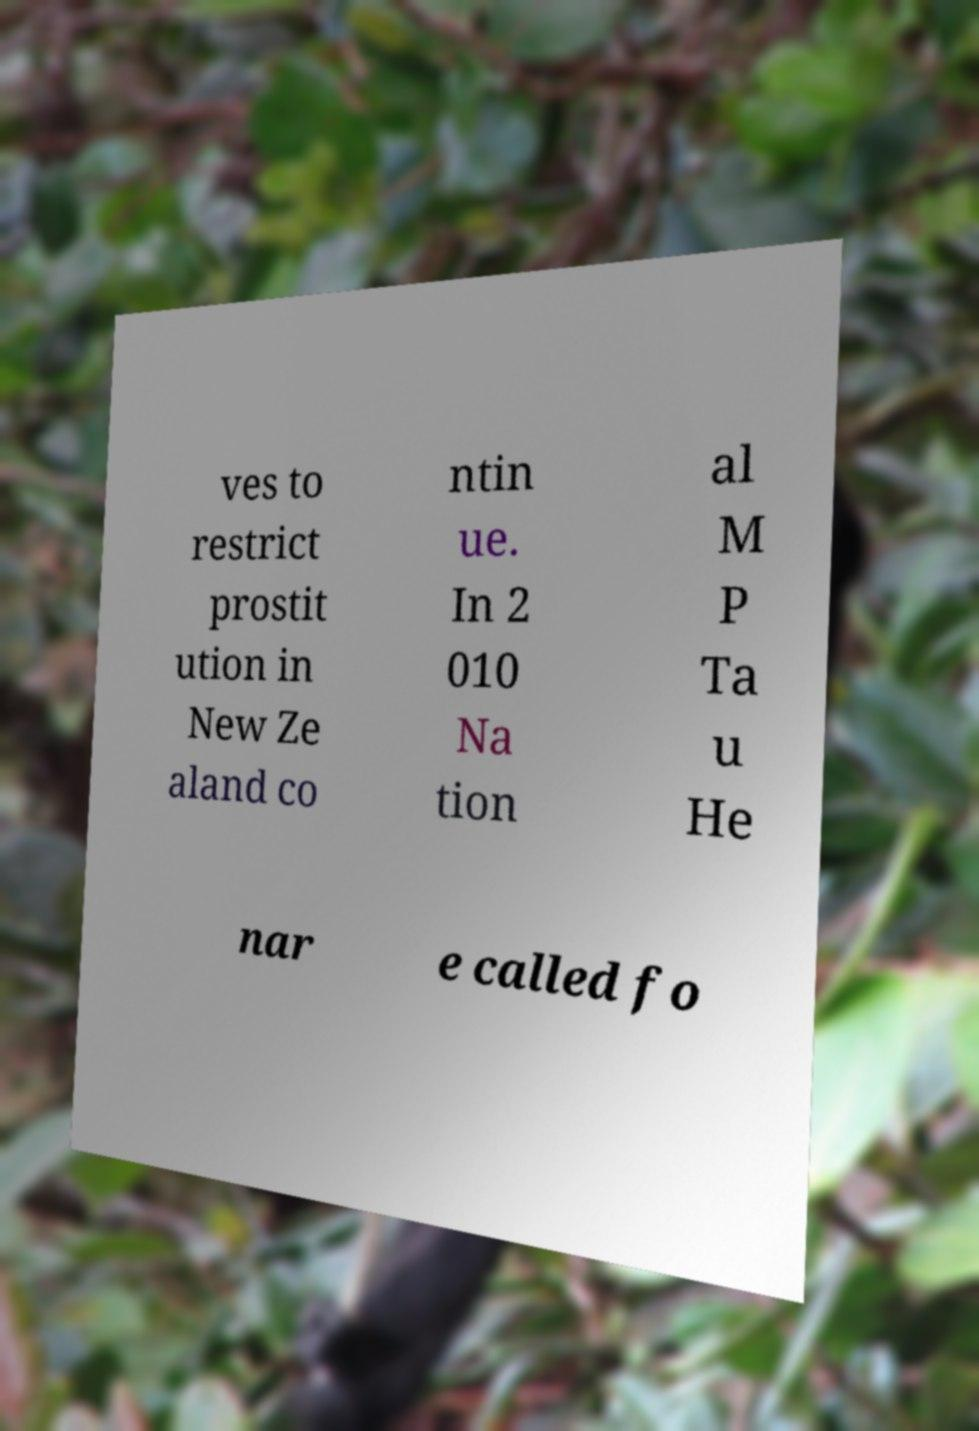Can you read and provide the text displayed in the image?This photo seems to have some interesting text. Can you extract and type it out for me? ves to restrict prostit ution in New Ze aland co ntin ue. In 2 010 Na tion al M P Ta u He nar e called fo 